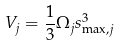<formula> <loc_0><loc_0><loc_500><loc_500>V _ { j } = \frac { 1 } { 3 } \Omega _ { j } s _ { \max , j } ^ { 3 }</formula> 